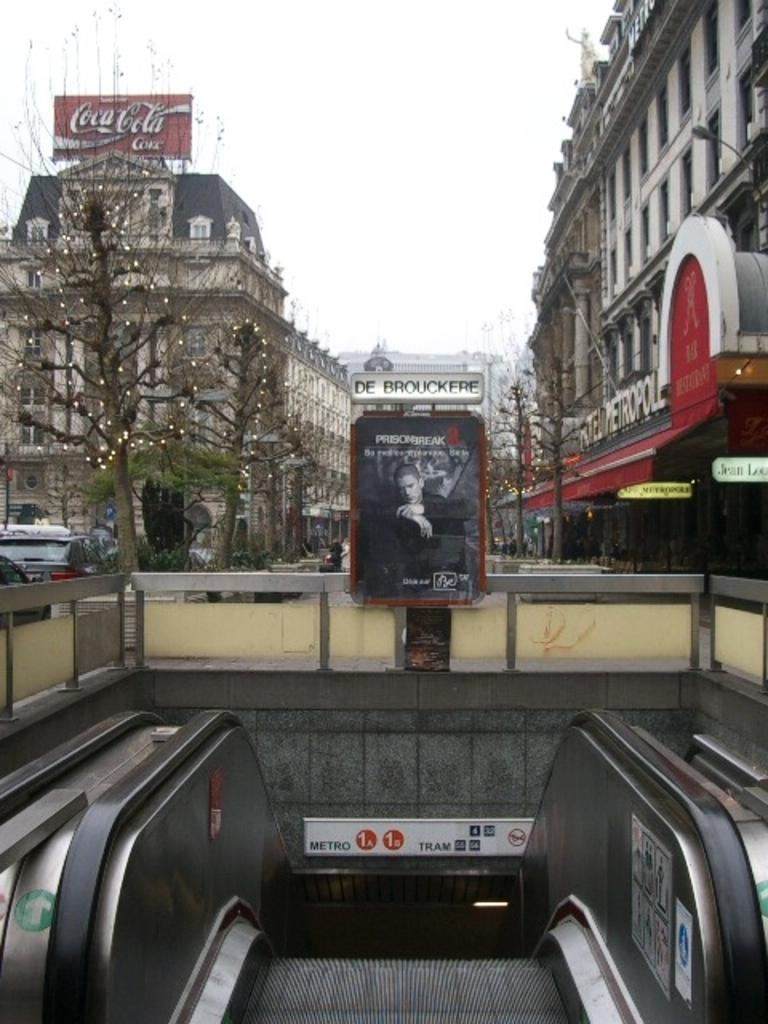What type of transportation device is present in the image? There is an escalator in the image. What object can be seen near the escalator? There is a board in the image. What can be seen on the road in the image? There are vehicles visible on the road in the image. What type of natural elements are visible in the background of the image? There are trees in the background of the image. What type of man-made structures are visible in the background of the image? There are buildings in the background of the image. What type of noise is the rat making in the image? There is no rat present in the image, so it is not possible to determine the noise it might be making. How does the behavior of the escalator change throughout the day in the image? The escalator is a stationary object and does not exhibit behavior, so it cannot change throughout the day in the image. 